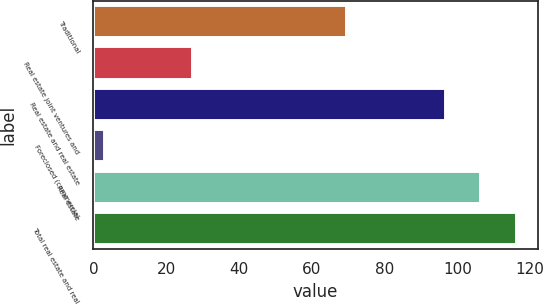<chart> <loc_0><loc_0><loc_500><loc_500><bar_chart><fcel>Traditional<fcel>Real estate joint ventures and<fcel>Real estate and real estate<fcel>Foreclosed (commercial<fcel>Real estate<fcel>Total real estate and real<nl><fcel>69.6<fcel>27.3<fcel>96.9<fcel>3.1<fcel>106.59<fcel>116.28<nl></chart> 